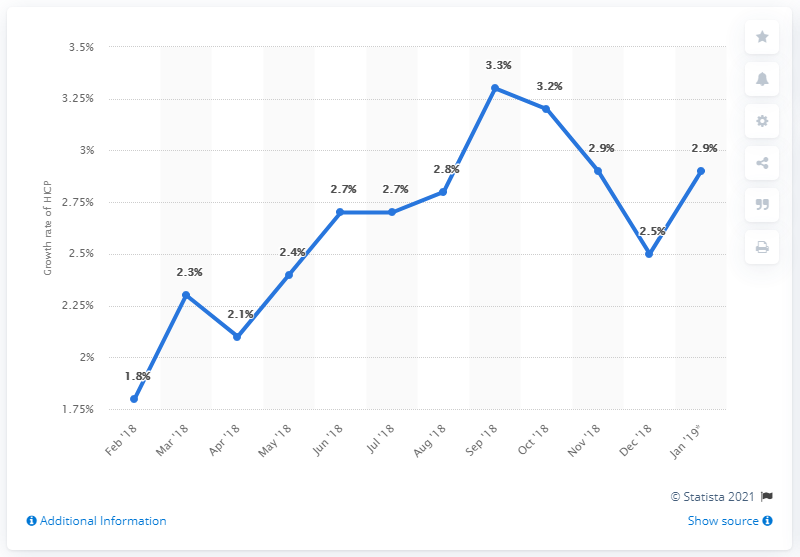Identify some key points in this picture. The downward peaks have a difference of 0.4. How many months out of the past 12 have a value for AV greater than 3%? 